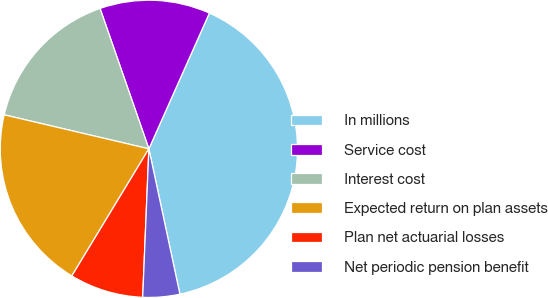<chart> <loc_0><loc_0><loc_500><loc_500><pie_chart><fcel>In millions<fcel>Service cost<fcel>Interest cost<fcel>Expected return on plan assets<fcel>Plan net actuarial losses<fcel>Net periodic pension benefit<nl><fcel>39.98%<fcel>12.0%<fcel>16.0%<fcel>20.0%<fcel>8.01%<fcel>4.01%<nl></chart> 